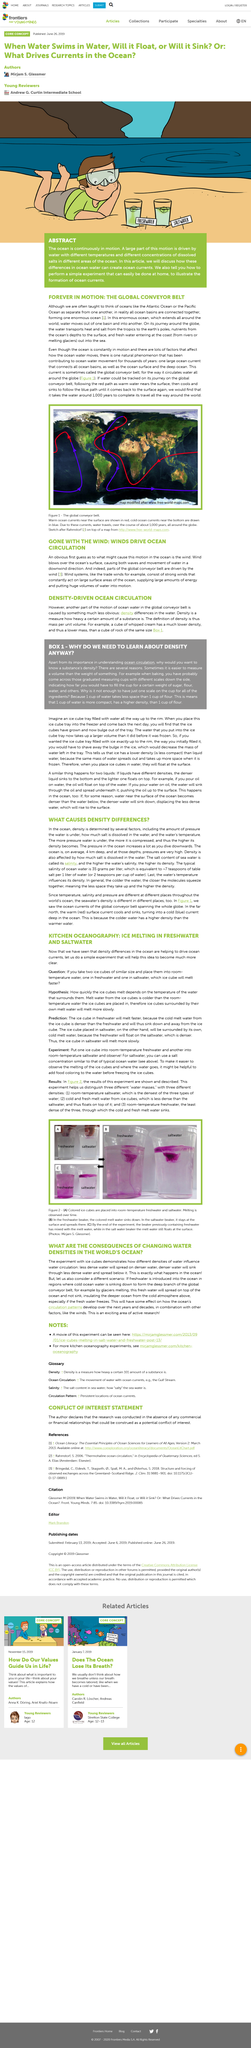Point out several critical features in this image. Water travels around the globe for approximately 1,000 years. The result of pouring oil onto water is that the oil will float on top of the water, clearly and objectively stated. Freshwater melts ice cubes faster due to the fact that the cold, denser meltwater from the ice cube sinks down and away from the ice cube, increasing the surface area of the freshwater in contact with the ice cube and accelerating the melting process. The melting experiment involves the use of various apparatus, including beakers, saltwater, freshwater, and colored ice cubes, in order to study the melting process of ice. Density is a physical property that describes how heavy a given amount of a substance is. 